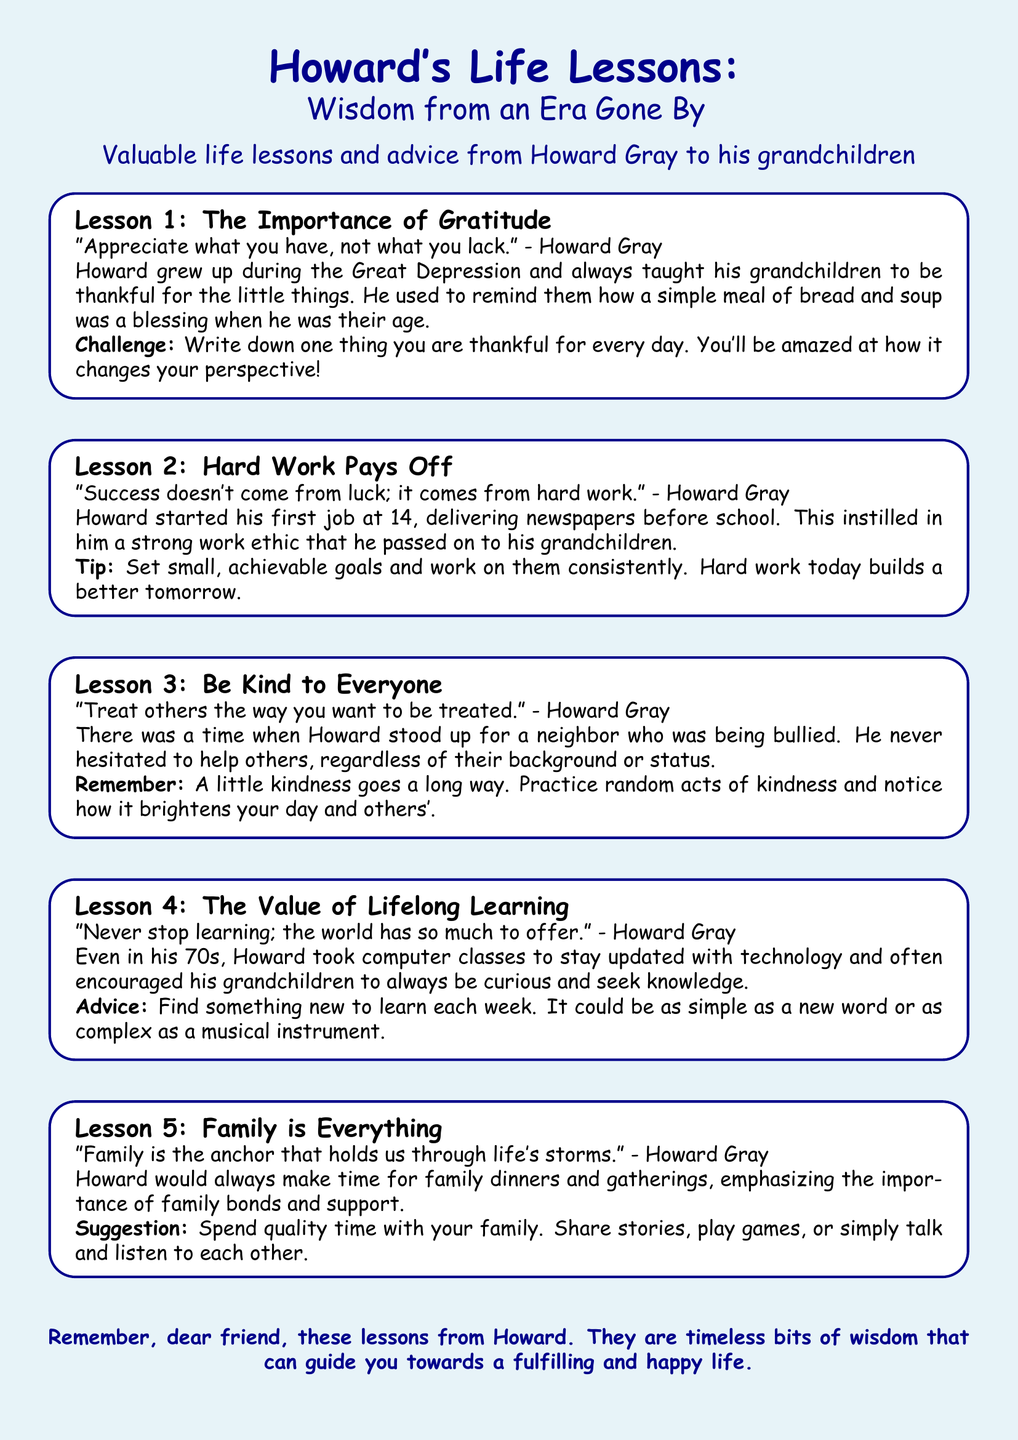What is the title of the flyer? The title is prominently displayed at the top of the document, introducing the main theme.
Answer: Howard's Life Lessons: Wisdom from an Era Gone By Who is the author of the lessons? The author of the lessons is mentioned in the flyer, stating his relation to the grandchildren.
Answer: Howard Gray What is Lesson 3 about? The lessons are summarized with specific topics, and Lesson 3 focuses on a particular virtue.
Answer: Be Kind to Everyone What age did Howard start his first job? The flyer details Howard's early work experience and specifies his starting age.
Answer: 14 What is the suggested challenge in Lesson 1? Each lesson includes a challenge or activity, and Lesson 1 has a specific suggestion for readers.
Answer: Write down one thing you are thankful for every day What is one example of Howard's advice on family? The document provides specific advice regarding family, emphasizing its importance.
Answer: Spend quality time with your family What did Howard learn even in his 70s? The flyer mentions Howard's commitment to learning throughout his life.
Answer: Computer classes What color is the background of the flyer? The color scheme of the flyer is described in the document, giving a visual detail about its design.
Answer: Light blue 